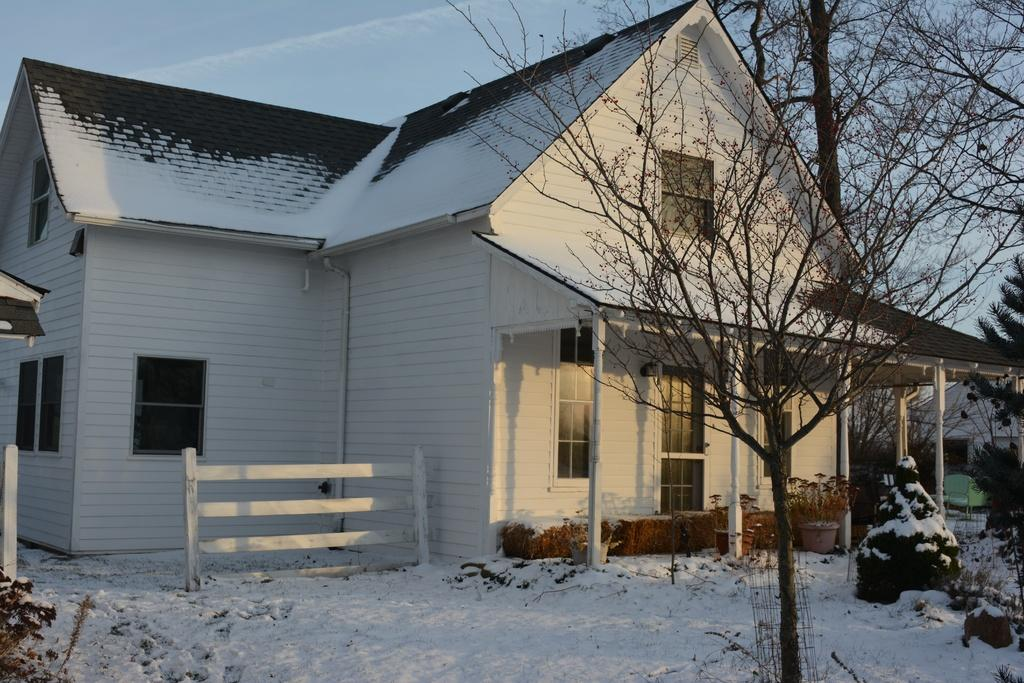What type of tree is in the image? There is a dried tree in the image. What structure can be seen in the background of the image? There is a house in the background of the image. What color is the house? The house is white. What is the condition of the trees in the background of the image? The trees in the background of the image are covered with snow. What color is the sky in the image? The sky is blue in the image. What type of ray can be seen swimming in the image? There is no ray present in the image; it features a dried tree, a white house, snow-covered trees, and a blue sky. 